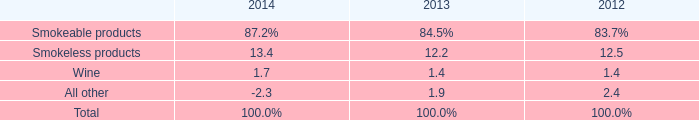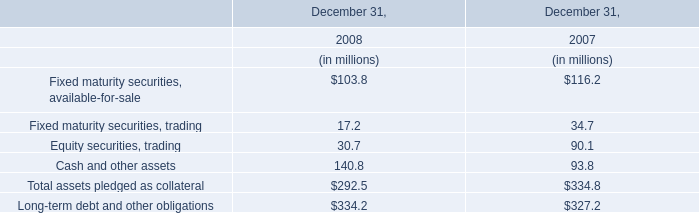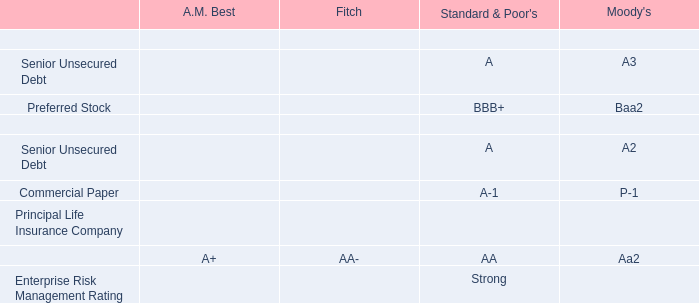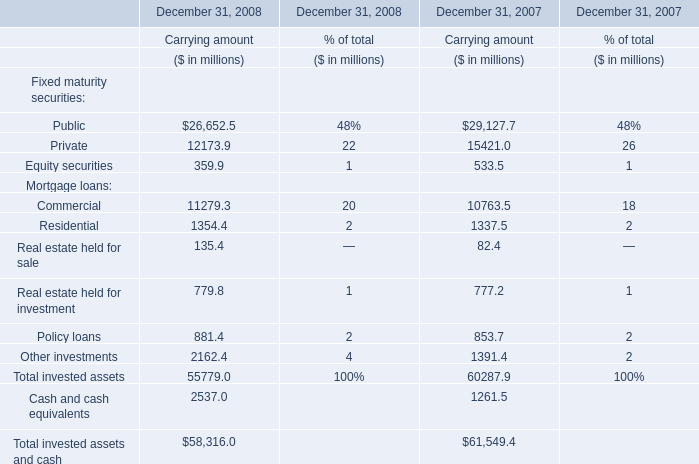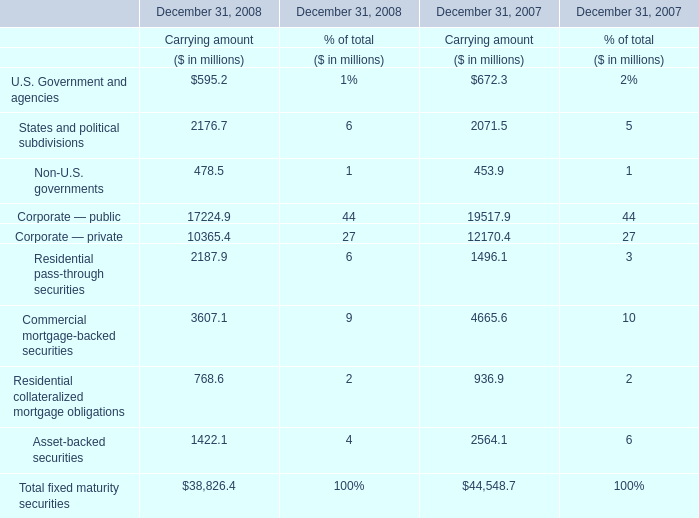In the year with largest amount of Public what's the increasing rate of Equity securities? 
Computations: ((533.5 - 359.9) / 533.5)
Answer: 0.3254. 